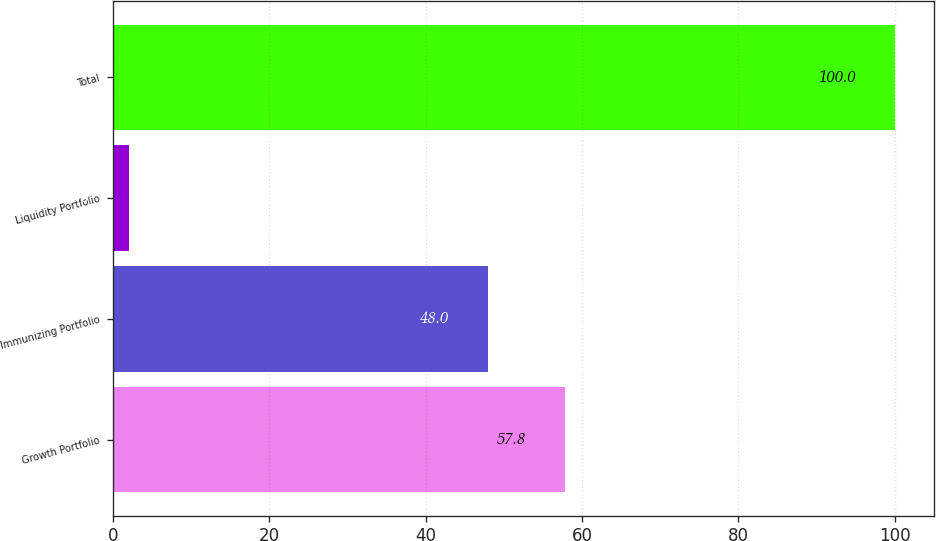<chart> <loc_0><loc_0><loc_500><loc_500><bar_chart><fcel>Growth Portfolio<fcel>Immunizing Portfolio<fcel>Liquidity Portfolio<fcel>Total<nl><fcel>57.8<fcel>48<fcel>2<fcel>100<nl></chart> 